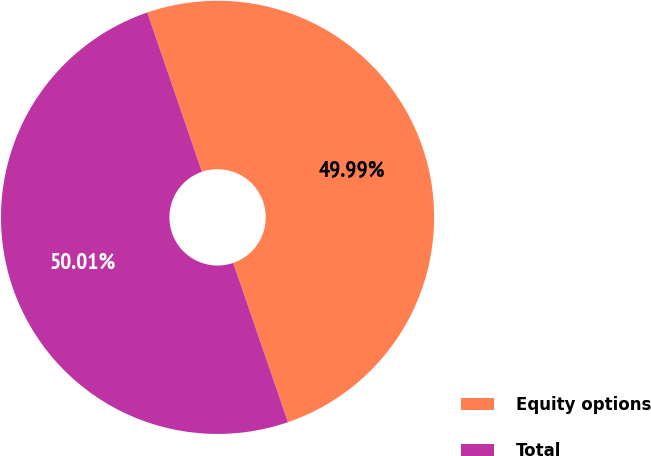Convert chart to OTSL. <chart><loc_0><loc_0><loc_500><loc_500><pie_chart><fcel>Equity options<fcel>Total<nl><fcel>49.99%<fcel>50.01%<nl></chart> 